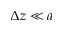Convert formula to latex. <formula><loc_0><loc_0><loc_500><loc_500>\Delta z \ll a</formula> 